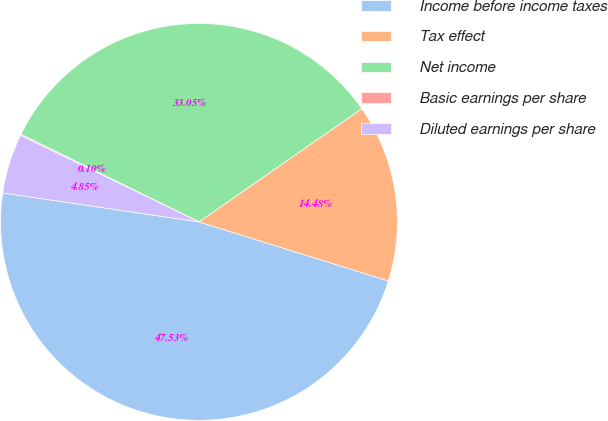<chart> <loc_0><loc_0><loc_500><loc_500><pie_chart><fcel>Income before income taxes<fcel>Tax effect<fcel>Net income<fcel>Basic earnings per share<fcel>Diluted earnings per share<nl><fcel>47.53%<fcel>14.48%<fcel>33.05%<fcel>0.1%<fcel>4.85%<nl></chart> 